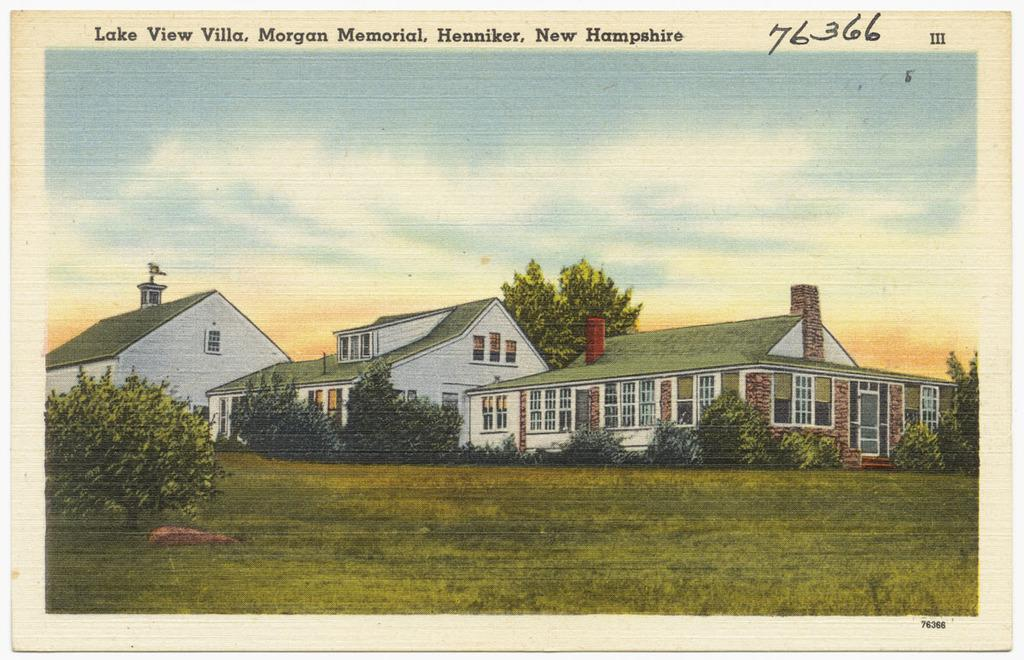<image>
Present a compact description of the photo's key features. a picture of a house on a page that says 'lake view villa. morgan memorial.' 